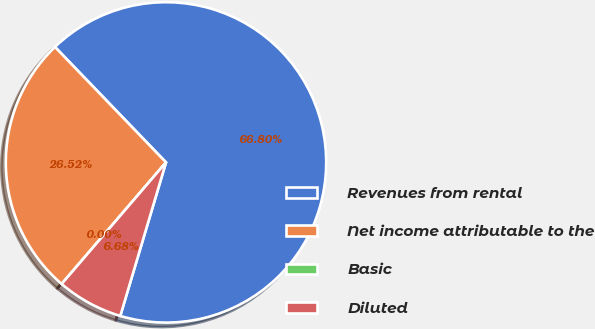Convert chart to OTSL. <chart><loc_0><loc_0><loc_500><loc_500><pie_chart><fcel>Revenues from rental<fcel>Net income attributable to the<fcel>Basic<fcel>Diluted<nl><fcel>66.8%<fcel>26.52%<fcel>0.0%<fcel>6.68%<nl></chart> 